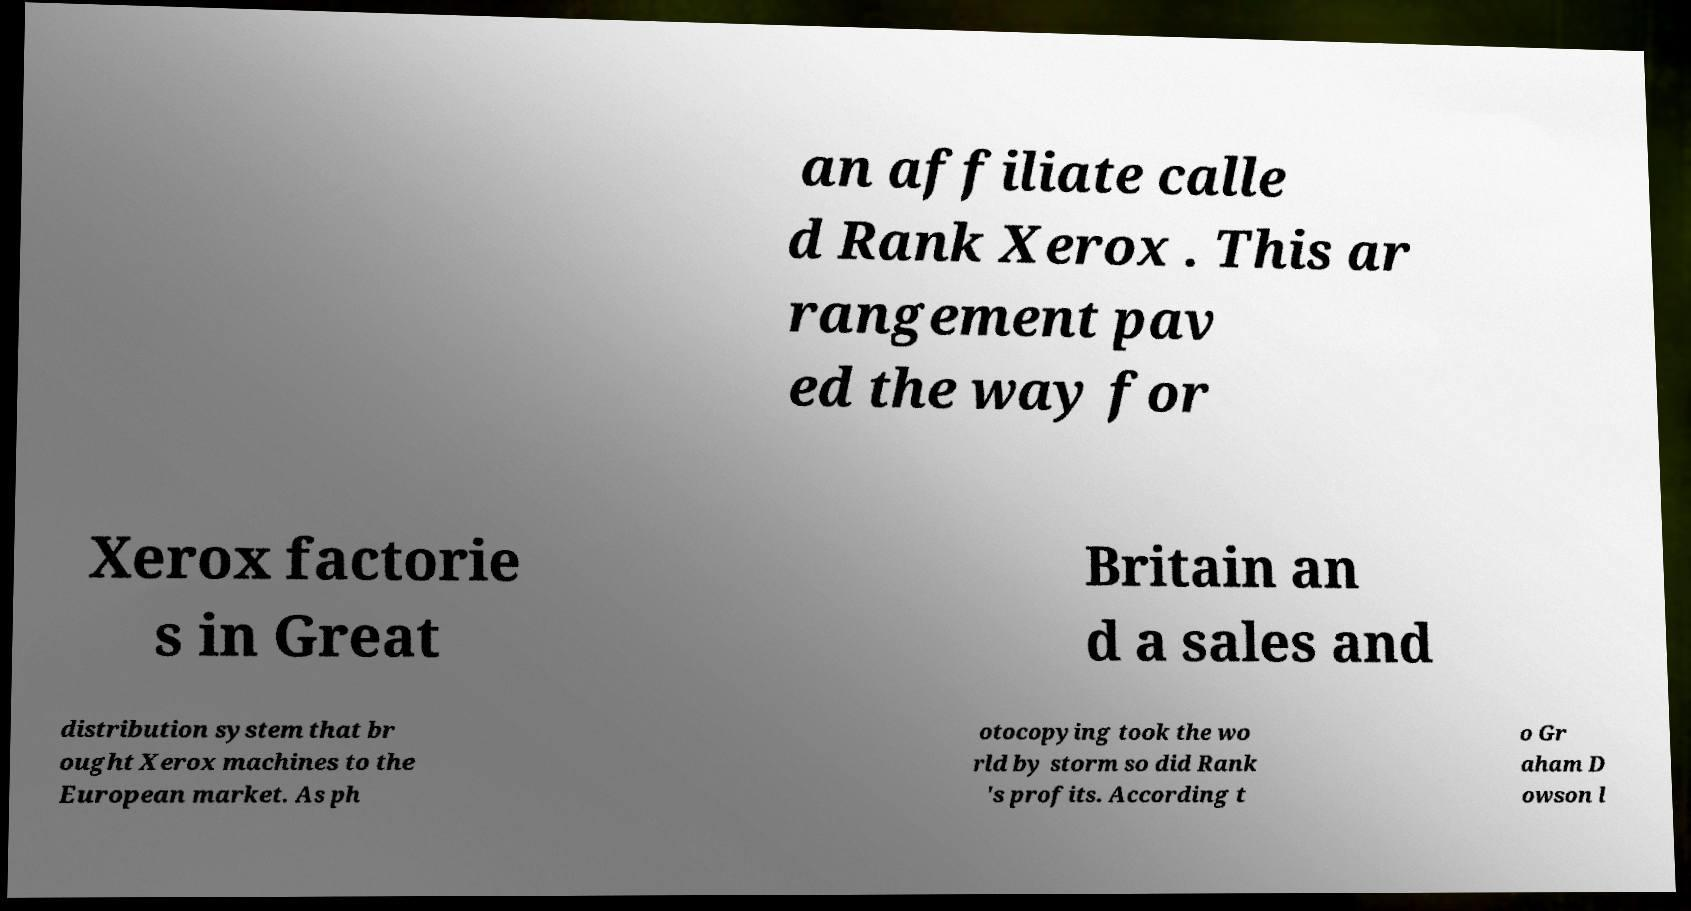Please identify and transcribe the text found in this image. an affiliate calle d Rank Xerox . This ar rangement pav ed the way for Xerox factorie s in Great Britain an d a sales and distribution system that br ought Xerox machines to the European market. As ph otocopying took the wo rld by storm so did Rank 's profits. According t o Gr aham D owson l 